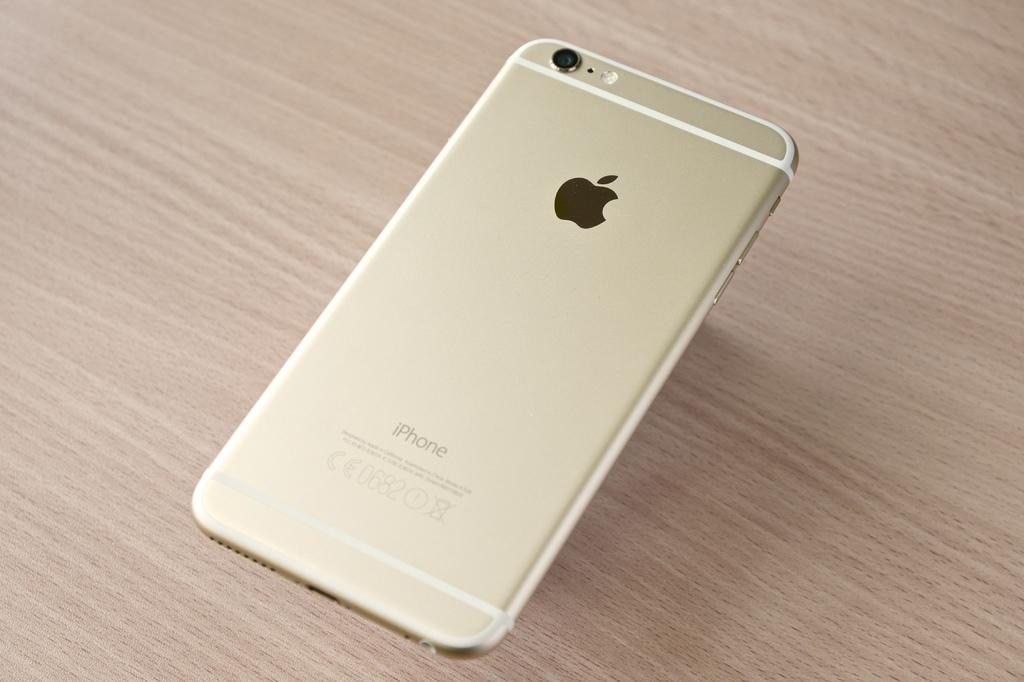Provide a one-sentence caption for the provided image. The back of an Apple iPhone numbered 0682. 